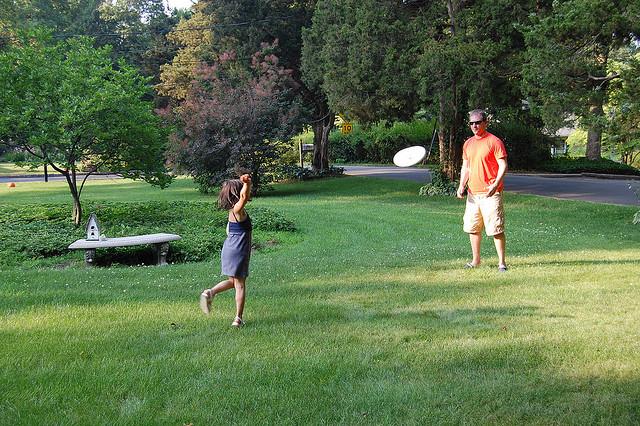Is this setting natural or is it cultivated?
Give a very brief answer. Cultivated. What color is the frisbee that is being used?
Be succinct. White. Does it look like this is the first time that girl has thrown a frisbee?
Keep it brief. No. 